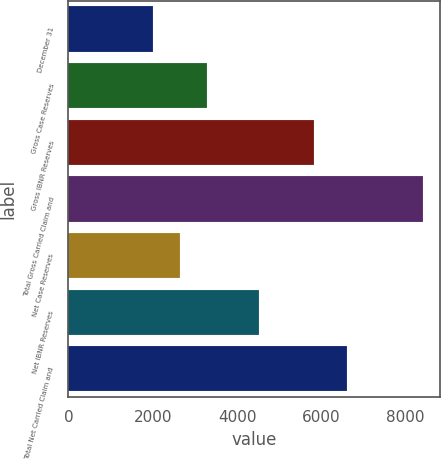Convert chart to OTSL. <chart><loc_0><loc_0><loc_500><loc_500><bar_chart><fcel>December 31<fcel>Gross Case Reserves<fcel>Gross IBNR Reserves<fcel>Total Gross Carried Claim and<fcel>Net Case Reserves<fcel>Net IBNR Reserves<fcel>Total Net Carried Claim and<nl><fcel>2007<fcel>3286.2<fcel>5818<fcel>8403<fcel>2646.6<fcel>4527<fcel>6617<nl></chart> 